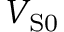<formula> <loc_0><loc_0><loc_500><loc_500>V _ { S 0 }</formula> 